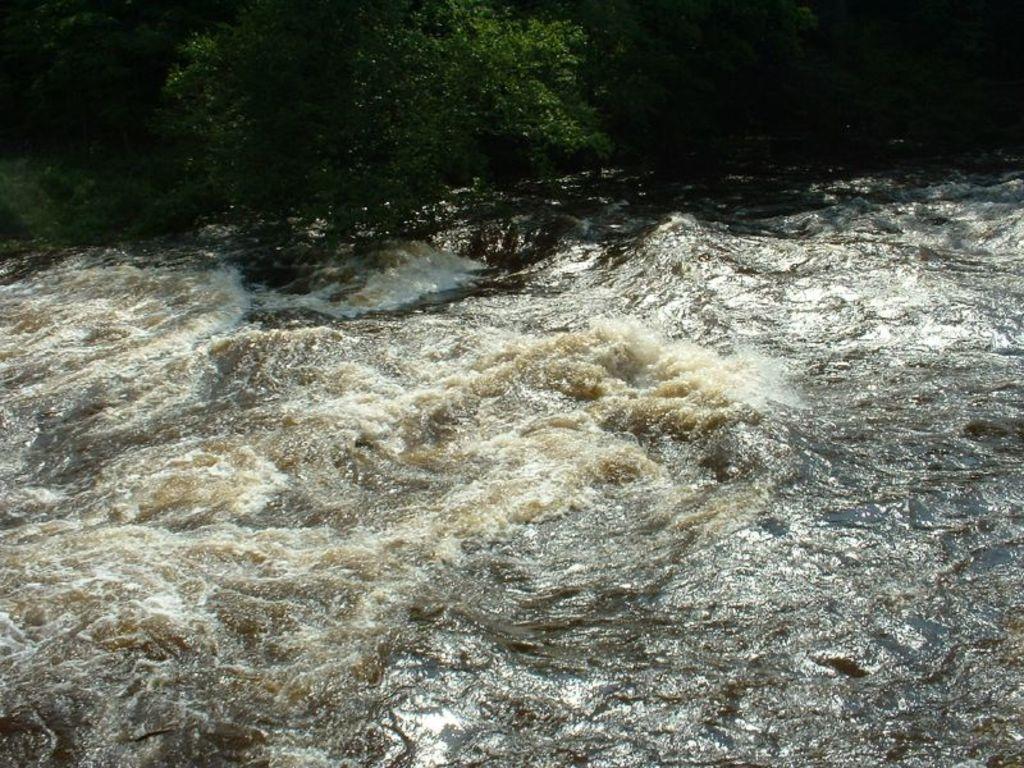How would you summarize this image in a sentence or two? In this image there is water truncated towards the bottom of the image, there are trees truncated towards the top of the image. 